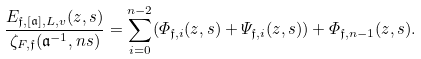<formula> <loc_0><loc_0><loc_500><loc_500>\frac { E _ { \mathfrak f , [ \mathfrak a ] , L , v } ( z , s ) } { \zeta _ { F , \mathfrak f } ( \mathfrak a ^ { - 1 } , n s ) } = \sum _ { i = 0 } ^ { n - 2 } ( \varPhi _ { \mathfrak f , i } ( z , s ) + \varPsi _ { \mathfrak f , i } ( z , s ) ) + \varPhi _ { \mathfrak f , n - 1 } ( z , s ) .</formula> 